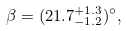Convert formula to latex. <formula><loc_0><loc_0><loc_500><loc_500>\beta = ( 2 1 . 7 ^ { + 1 . 3 } _ { - 1 . 2 } ) ^ { \circ } ,</formula> 